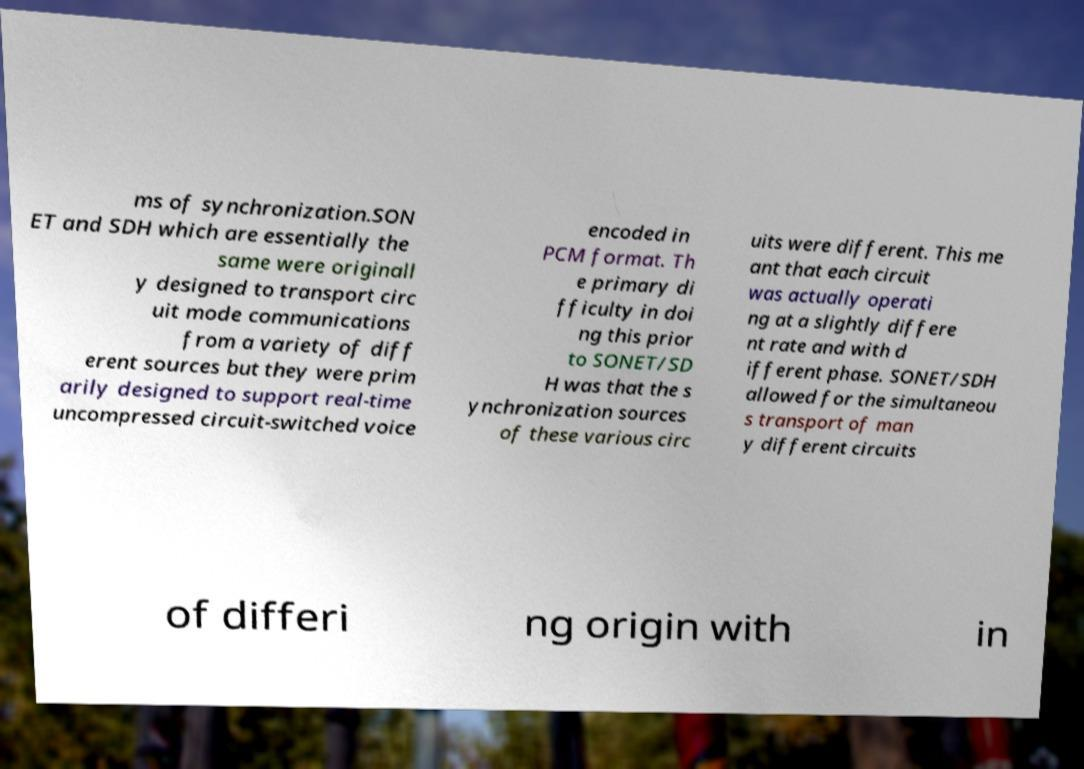Could you assist in decoding the text presented in this image and type it out clearly? ms of synchronization.SON ET and SDH which are essentially the same were originall y designed to transport circ uit mode communications from a variety of diff erent sources but they were prim arily designed to support real-time uncompressed circuit-switched voice encoded in PCM format. Th e primary di fficulty in doi ng this prior to SONET/SD H was that the s ynchronization sources of these various circ uits were different. This me ant that each circuit was actually operati ng at a slightly differe nt rate and with d ifferent phase. SONET/SDH allowed for the simultaneou s transport of man y different circuits of differi ng origin with in 